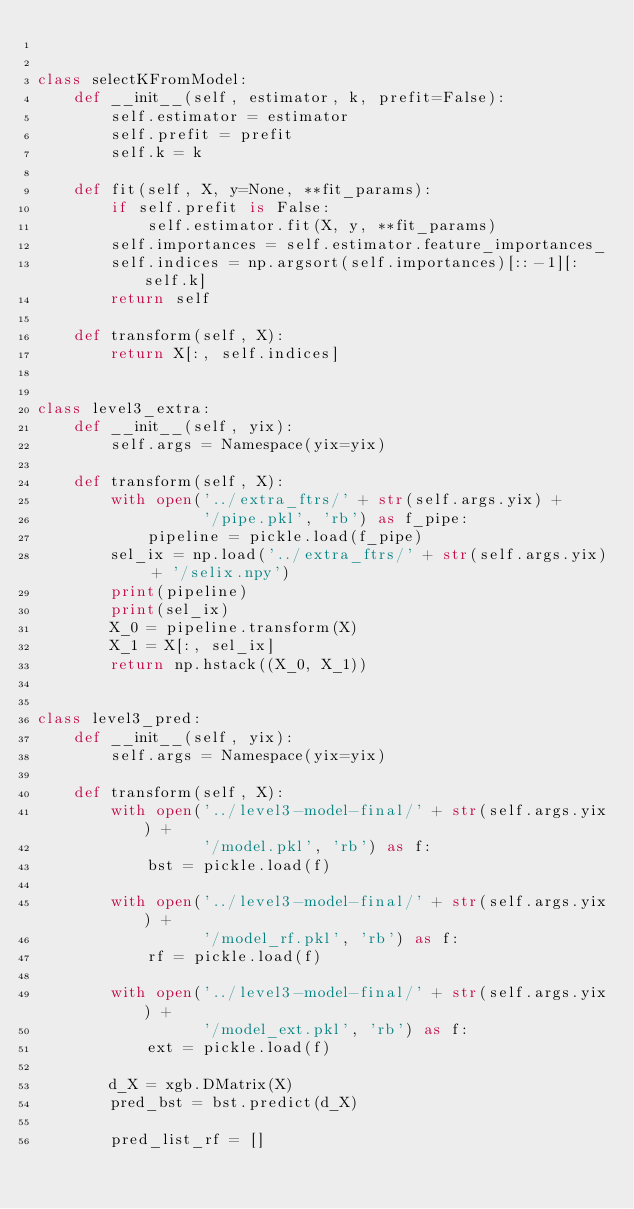<code> <loc_0><loc_0><loc_500><loc_500><_Python_>

class selectKFromModel:
    def __init__(self, estimator, k, prefit=False):
        self.estimator = estimator
        self.prefit = prefit
        self.k = k

    def fit(self, X, y=None, **fit_params):
        if self.prefit is False:
            self.estimator.fit(X, y, **fit_params)
        self.importances = self.estimator.feature_importances_
        self.indices = np.argsort(self.importances)[::-1][:self.k]
        return self

    def transform(self, X):
        return X[:, self.indices]


class level3_extra:
    def __init__(self, yix):
        self.args = Namespace(yix=yix)

    def transform(self, X):
        with open('../extra_ftrs/' + str(self.args.yix) +
                  '/pipe.pkl', 'rb') as f_pipe:
            pipeline = pickle.load(f_pipe)
        sel_ix = np.load('../extra_ftrs/' + str(self.args.yix) + '/selix.npy')
        print(pipeline)
        print(sel_ix)
        X_0 = pipeline.transform(X)
        X_1 = X[:, sel_ix]
        return np.hstack((X_0, X_1))


class level3_pred:
    def __init__(self, yix):
        self.args = Namespace(yix=yix)

    def transform(self, X):
        with open('../level3-model-final/' + str(self.args.yix) +
                  '/model.pkl', 'rb') as f:
            bst = pickle.load(f)

        with open('../level3-model-final/' + str(self.args.yix) +
                  '/model_rf.pkl', 'rb') as f:
            rf = pickle.load(f)

        with open('../level3-model-final/' + str(self.args.yix) +
                  '/model_ext.pkl', 'rb') as f:
            ext = pickle.load(f)

        d_X = xgb.DMatrix(X)
        pred_bst = bst.predict(d_X)

        pred_list_rf = []</code> 